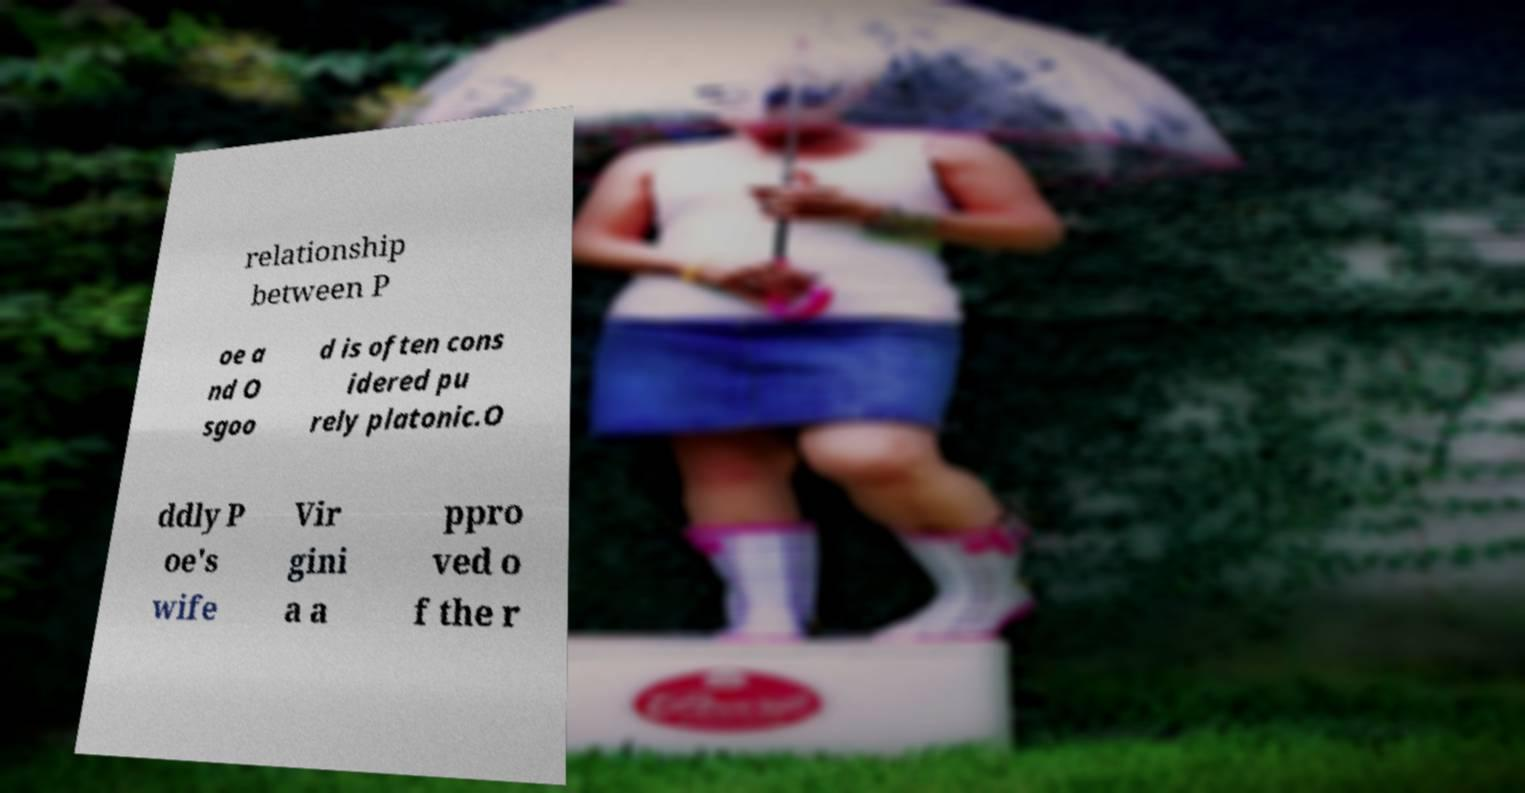I need the written content from this picture converted into text. Can you do that? relationship between P oe a nd O sgoo d is often cons idered pu rely platonic.O ddly P oe's wife Vir gini a a ppro ved o f the r 